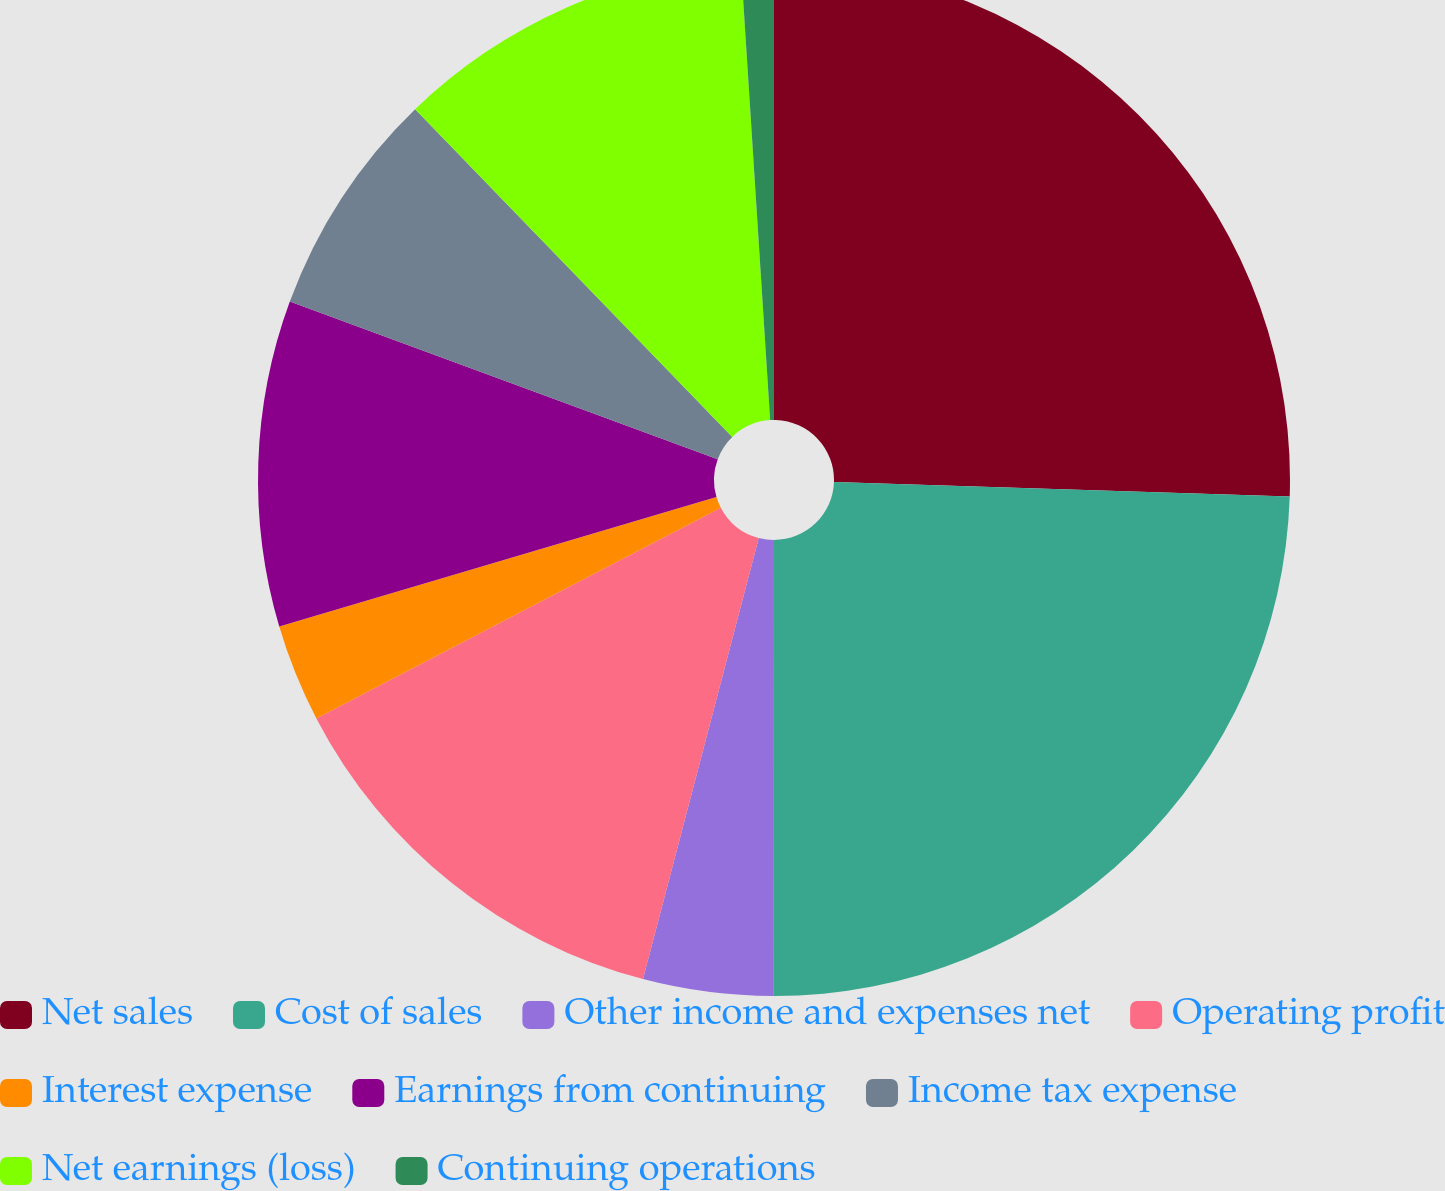Convert chart to OTSL. <chart><loc_0><loc_0><loc_500><loc_500><pie_chart><fcel>Net sales<fcel>Cost of sales<fcel>Other income and expenses net<fcel>Operating profit<fcel>Interest expense<fcel>Earnings from continuing<fcel>Income tax expense<fcel>Net earnings (loss)<fcel>Continuing operations<nl><fcel>25.51%<fcel>24.49%<fcel>4.08%<fcel>13.27%<fcel>3.06%<fcel>10.2%<fcel>7.14%<fcel>11.22%<fcel>1.02%<nl></chart> 